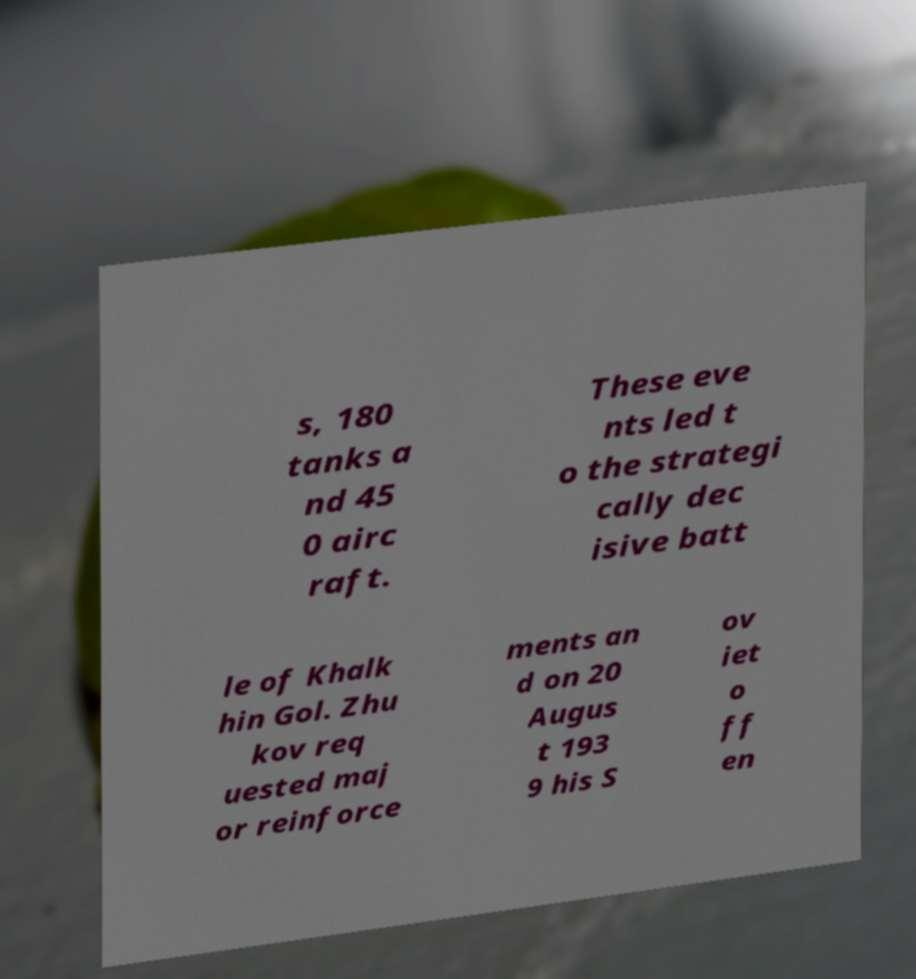What messages or text are displayed in this image? I need them in a readable, typed format. s, 180 tanks a nd 45 0 airc raft. These eve nts led t o the strategi cally dec isive batt le of Khalk hin Gol. Zhu kov req uested maj or reinforce ments an d on 20 Augus t 193 9 his S ov iet o ff en 